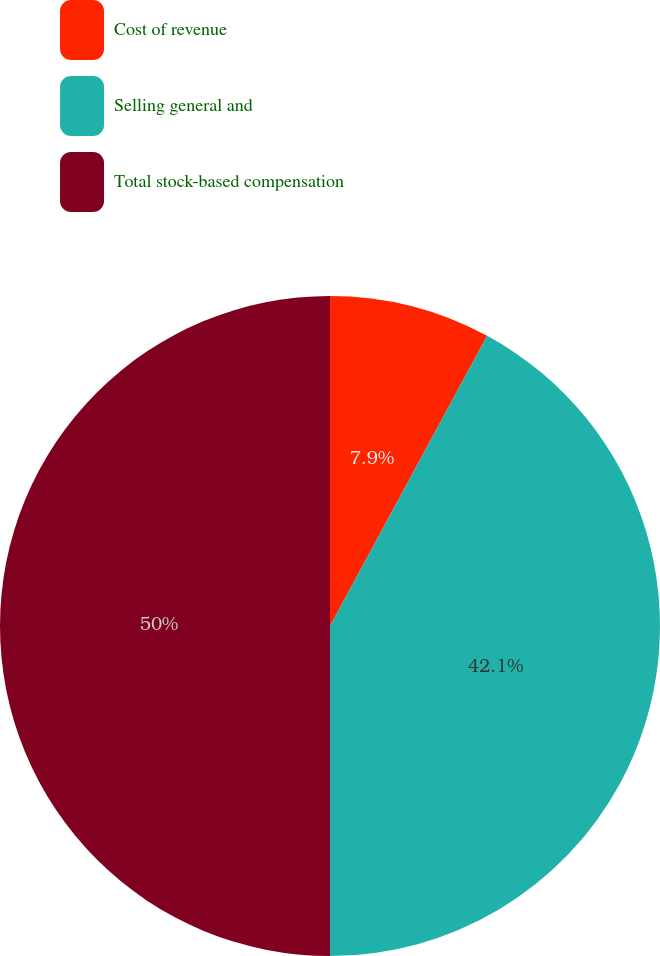Convert chart. <chart><loc_0><loc_0><loc_500><loc_500><pie_chart><fcel>Cost of revenue<fcel>Selling general and<fcel>Total stock-based compensation<nl><fcel>7.9%<fcel>42.1%<fcel>50.0%<nl></chart> 